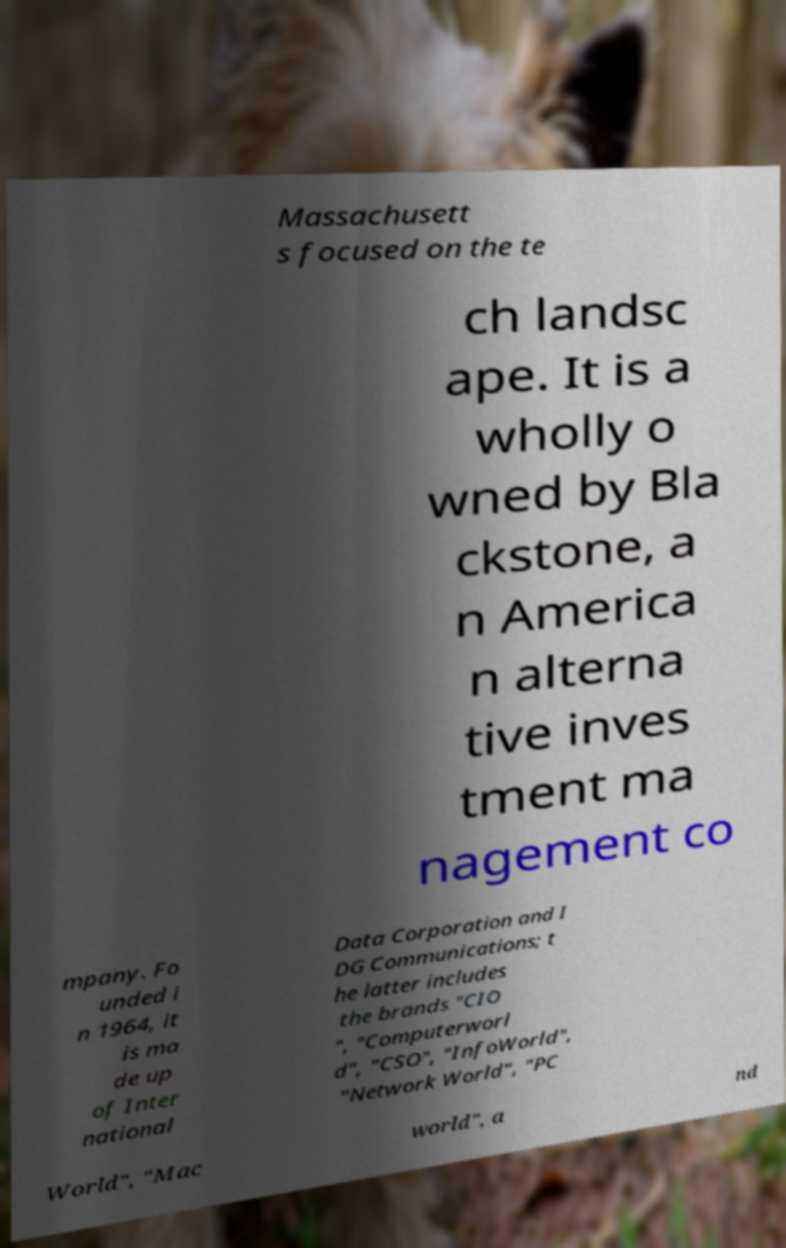Can you read and provide the text displayed in the image?This photo seems to have some interesting text. Can you extract and type it out for me? Massachusett s focused on the te ch landsc ape. It is a wholly o wned by Bla ckstone, a n America n alterna tive inves tment ma nagement co mpany. Fo unded i n 1964, it is ma de up of Inter national Data Corporation and I DG Communications; t he latter includes the brands "CIO ", "Computerworl d", "CSO", "InfoWorld", "Network World", "PC World", "Mac world", a nd 